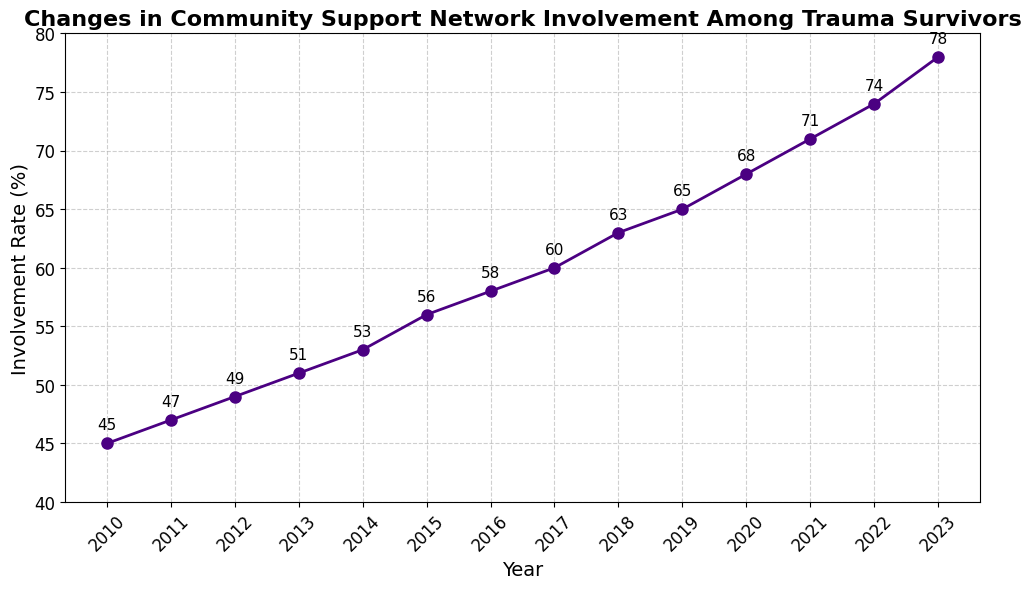What is the overall trend in community support network involvement rate among trauma survivors over the years? To identify the trend, we examine the involvement rates from 2010 to 2023 in the chart. We observe that the involvement rate consistently increases every year.
Answer: Increasing Which year saw the highest increase in involvement rate compared to the previous year? To determine this, we need to compare the year-on-year increase in the involvement rate. The most significant increase is between 2022 (74%) and 2023 (78%), with an increase of 4%.
Answer: 2023 What is the difference in involvement rate between the years 2010 and 2023? Subtract the involvement rate in 2010 (45%) from the involvement rate in 2023 (78%). This results in a difference of 33%.
Answer: 33% What was the involvement rate in 2015? Locate the year 2015 on the x-axis and follow it up to the y-axis to find the involvement rate. The rate for 2015 is at 56%.
Answer: 56% How does the involvement rate in 2020 compare to that in 2019? Compare the y-axis values for the years 2020 (68%) and 2019 (65%). The involvement rate increased by 3% from 2019 to 2020.
Answer: 3% Between which consecutive years did the involvement rate see just a 2% increase? By comparing the year-on-year changes, we find that from 2010 (45%) to 2011 (47%), there is an increase of 2%.
Answer: 2010 to 2011 In which years did the involvement rate reach or exceed 60%? Check the y-axis values to see when they reach or exceed 60%. The involvement rates reached or exceeded 60% from 2017 onwards.
Answer: 2017, 2018, 2019, 2020, 2021, 2022, 2023 What's the average involvement rate over the years 2010 to 2023? Sum up the involvement rates from 2010 to 2023 (45 + 47 + 49 + 51 + 53 + 56 + 58 + 60 + 63 + 65 + 68 + 71 + 74 + 78) and divide by the number of years (14). This totals to 808, so the average rate is 808/14 ≈ 57.71%.
Answer: 57.71 Determine the median involvement rate from 2010 to 2023. List the involvement rates in ascending order: 45, 47, 49, 51, 53, 56, 58, 60, 63, 65, 68, 71, 74, 78. The median of these 14 values is the average of the 7th and 8th values: (58 + 60) / 2 = 59%.
Answer: 59% What is the involvement rate annotated next to the marker for the year 2014? Each marker on the plot is annotated with its value. For 2014, the annotated involvement rate is 53%.
Answer: 53% 